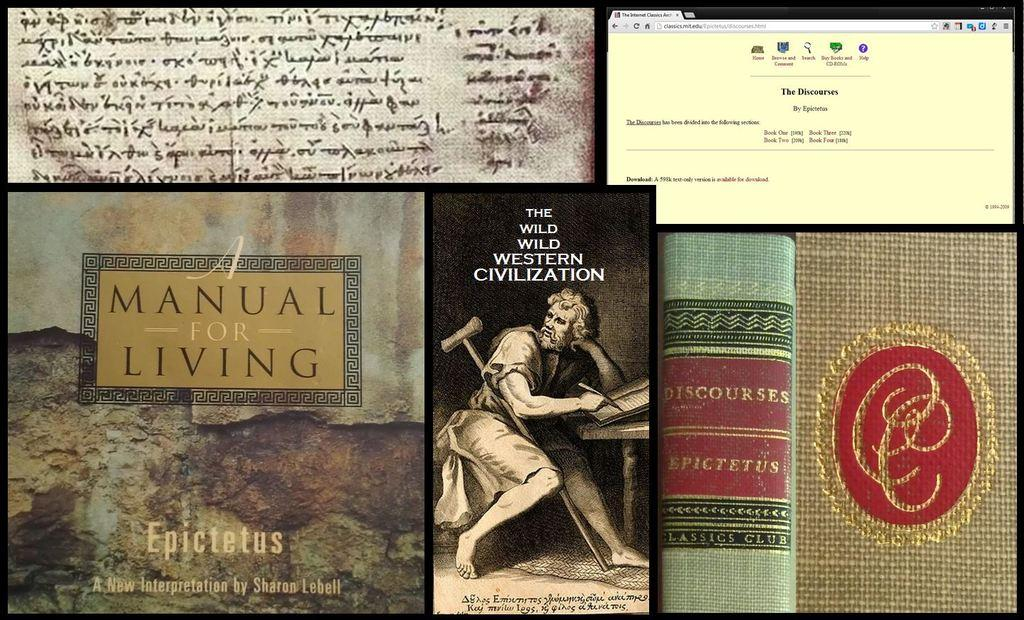<image>
Describe the image concisely. A collection of old books with one titled A Manual for Living. 